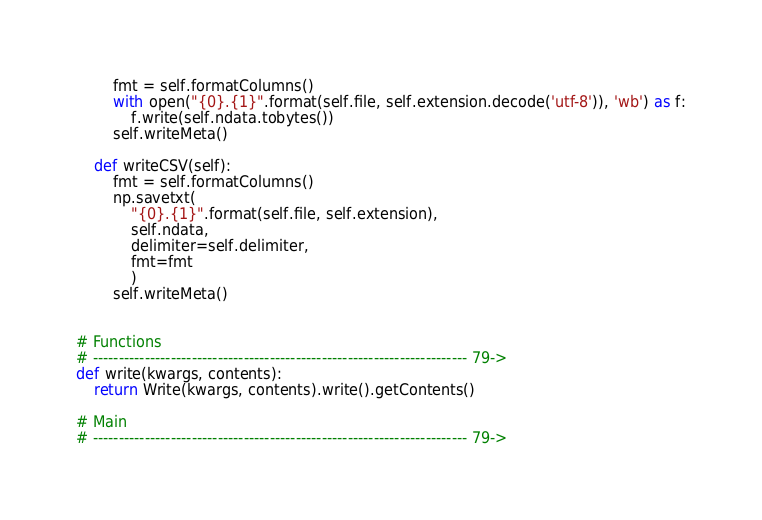Convert code to text. <code><loc_0><loc_0><loc_500><loc_500><_Python_>        fmt = self.formatColumns()
        with open("{0}.{1}".format(self.file, self.extension.decode('utf-8')), 'wb') as f:
            f.write(self.ndata.tobytes())
        self.writeMeta()

    def writeCSV(self):
        fmt = self.formatColumns()
        np.savetxt(
            "{0}.{1}".format(self.file, self.extension), 
            self.ndata,
            delimiter=self.delimiter,
            fmt=fmt
            )
        self.writeMeta()


# Functions
# ------------------------------------------------------------------------ 79->
def write(kwargs, contents):
    return Write(kwargs, contents).write().getContents()

# Main
# ------------------------------------------------------------------------ 79->
</code> 